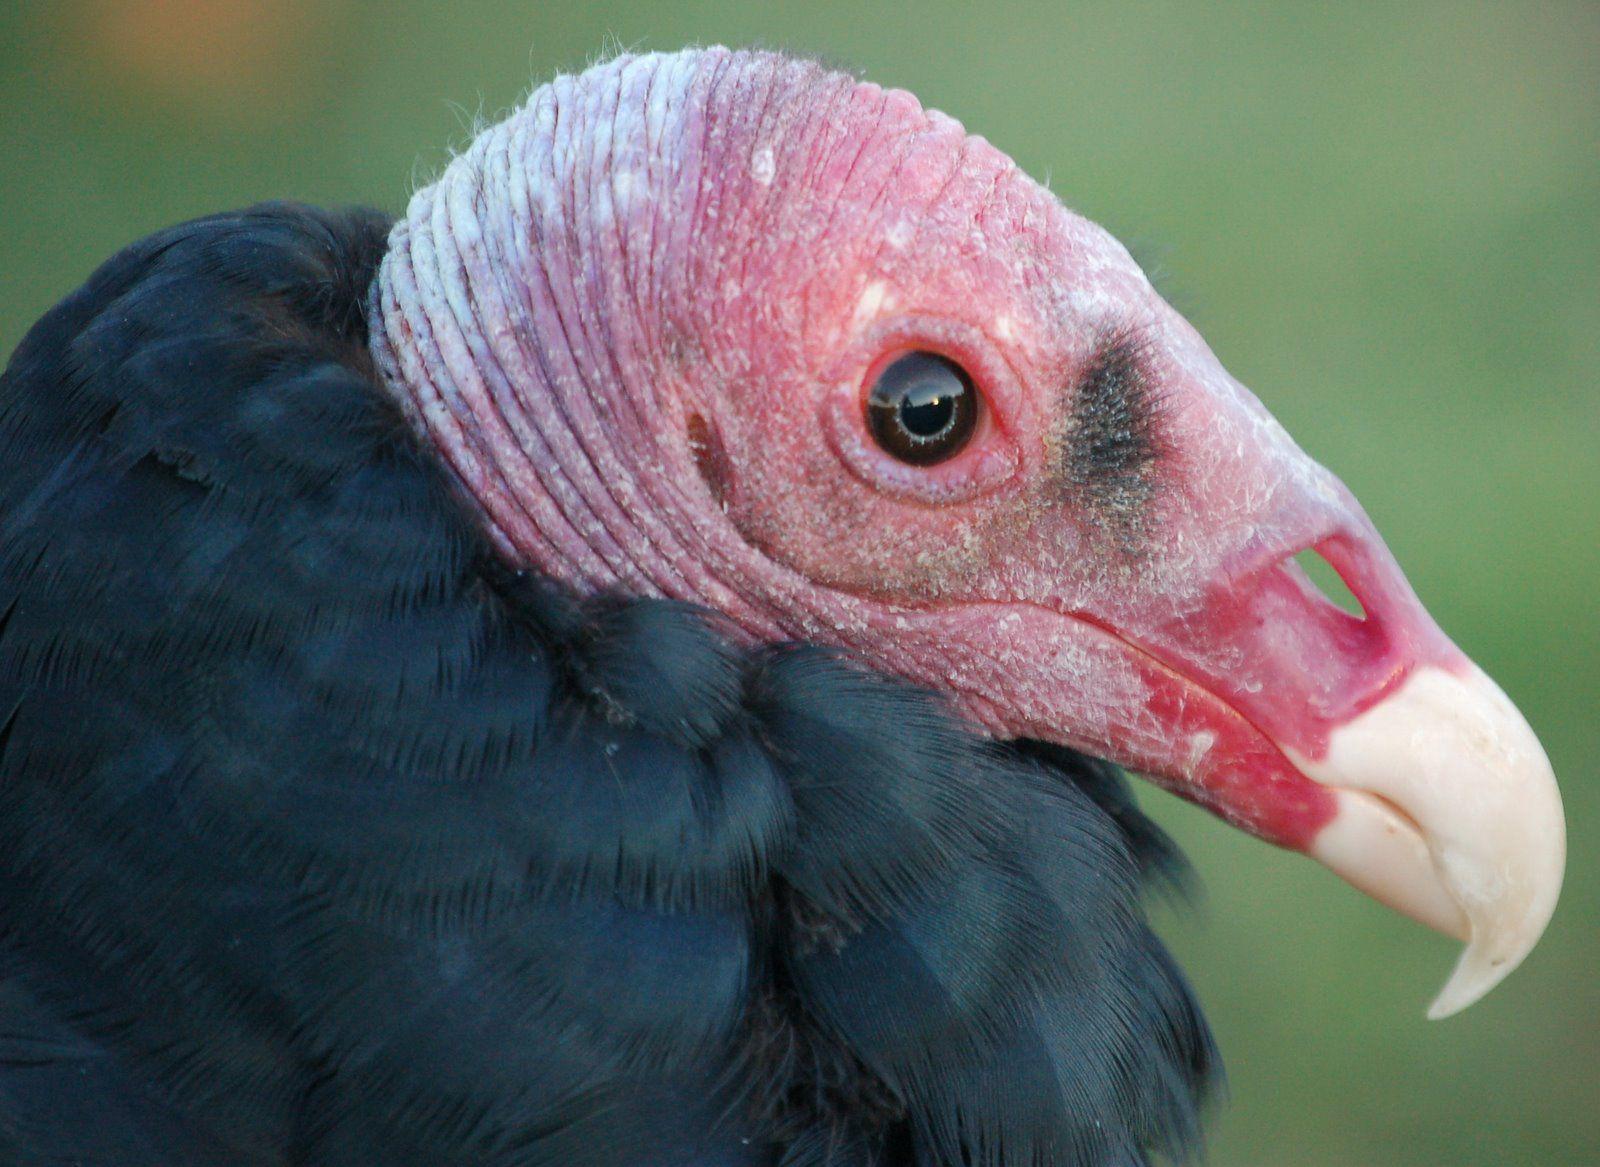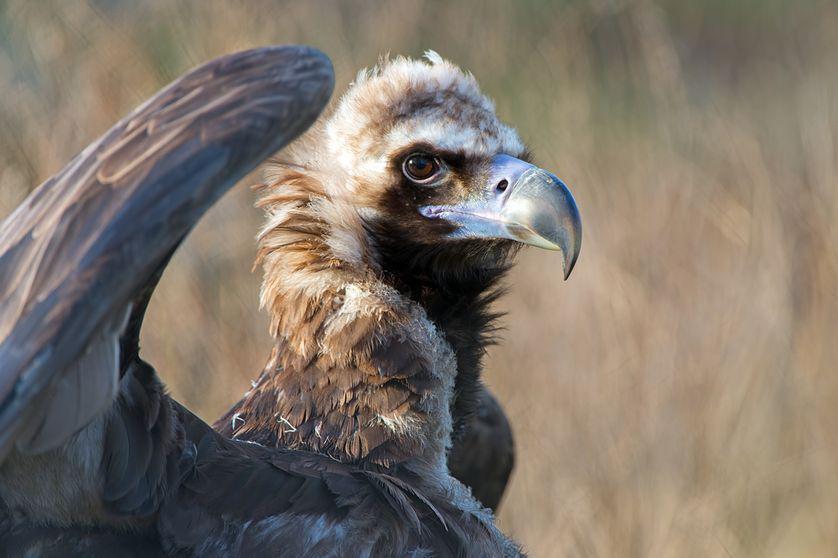The first image is the image on the left, the second image is the image on the right. Evaluate the accuracy of this statement regarding the images: "A bird has a raised wing in one image.". Is it true? Answer yes or no. Yes. 